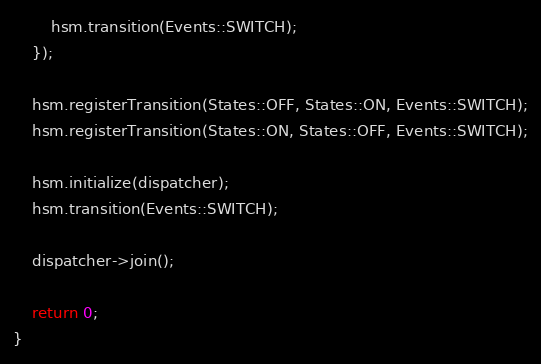Convert code to text. <code><loc_0><loc_0><loc_500><loc_500><_C++_>        hsm.transition(Events::SWITCH);
    });

    hsm.registerTransition(States::OFF, States::ON, Events::SWITCH);
    hsm.registerTransition(States::ON, States::OFF, Events::SWITCH);

    hsm.initialize(dispatcher);
    hsm.transition(Events::SWITCH);

    dispatcher->join();

    return 0;
}</code> 